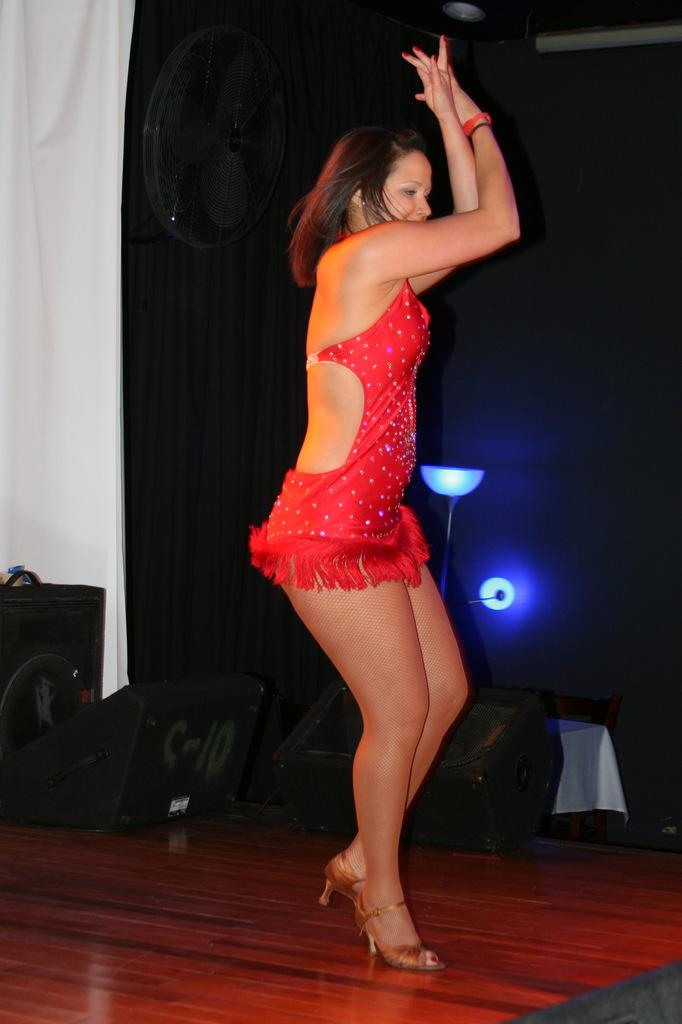Who is present in the image? There is a woman in the image. What is the woman's position in the image? The woman is on the floor. What can be seen in the background of the image? There are clothes, lights, and other objects in the background of the image. Can you tell me how many goats are in the image? There are no goats present in the image. What type of arch can be seen in the background of the image? There is no arch present in the image; only clothes, lights, and other objects are visible in the background. 